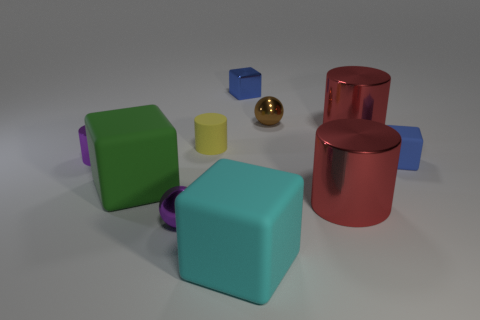Is the number of purple spheres in front of the cyan block less than the number of blue metal things?
Keep it short and to the point. Yes. There is a cyan object that is the same shape as the blue metallic thing; what material is it?
Give a very brief answer. Rubber. There is a big object that is both on the right side of the large green rubber thing and to the left of the small blue metal cube; what shape is it?
Make the answer very short. Cube. The other large thing that is made of the same material as the big green object is what shape?
Offer a very short reply. Cube. There is a cube left of the small purple ball; what is it made of?
Provide a short and direct response. Rubber. Is the size of the matte block that is behind the green object the same as the red shiny cylinder that is behind the small yellow rubber object?
Your answer should be compact. No. The small matte cylinder is what color?
Provide a short and direct response. Yellow. There is a big red object behind the yellow object; does it have the same shape as the blue rubber thing?
Make the answer very short. No. What is the tiny purple cylinder made of?
Give a very brief answer. Metal. There is a blue rubber thing that is the same size as the yellow thing; what is its shape?
Offer a very short reply. Cube. 